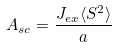Convert formula to latex. <formula><loc_0><loc_0><loc_500><loc_500>A _ { s c } = { \frac { J _ { e x } \langle S ^ { 2 } \rangle } { a } }</formula> 